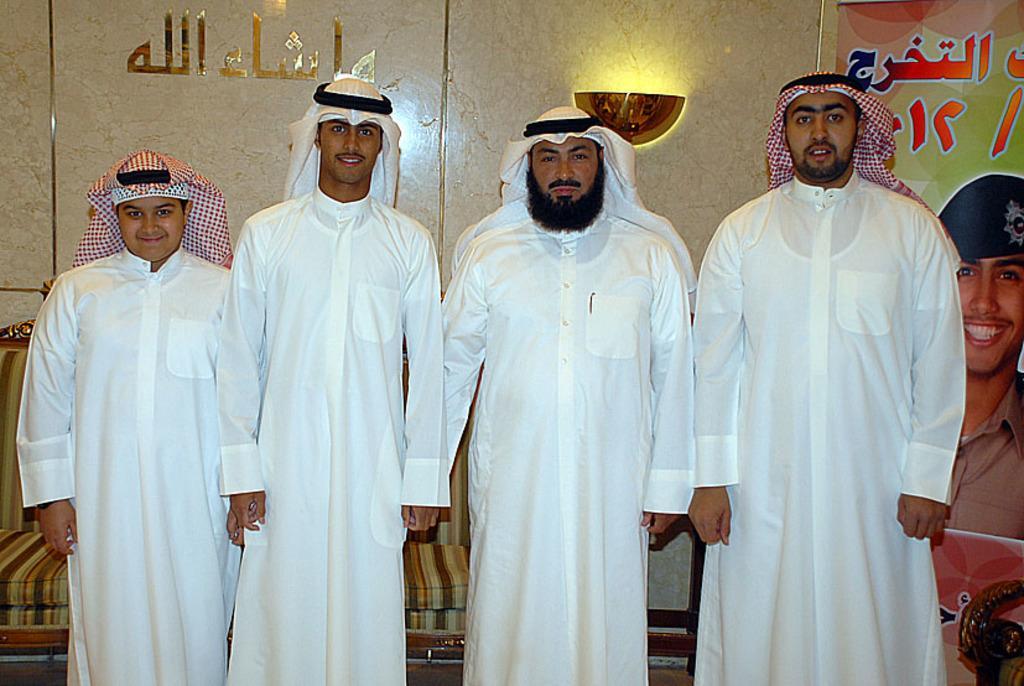Describe this image in one or two sentences. Front these four people are standing. Background there is a light on the wall, hoarding and couch. 